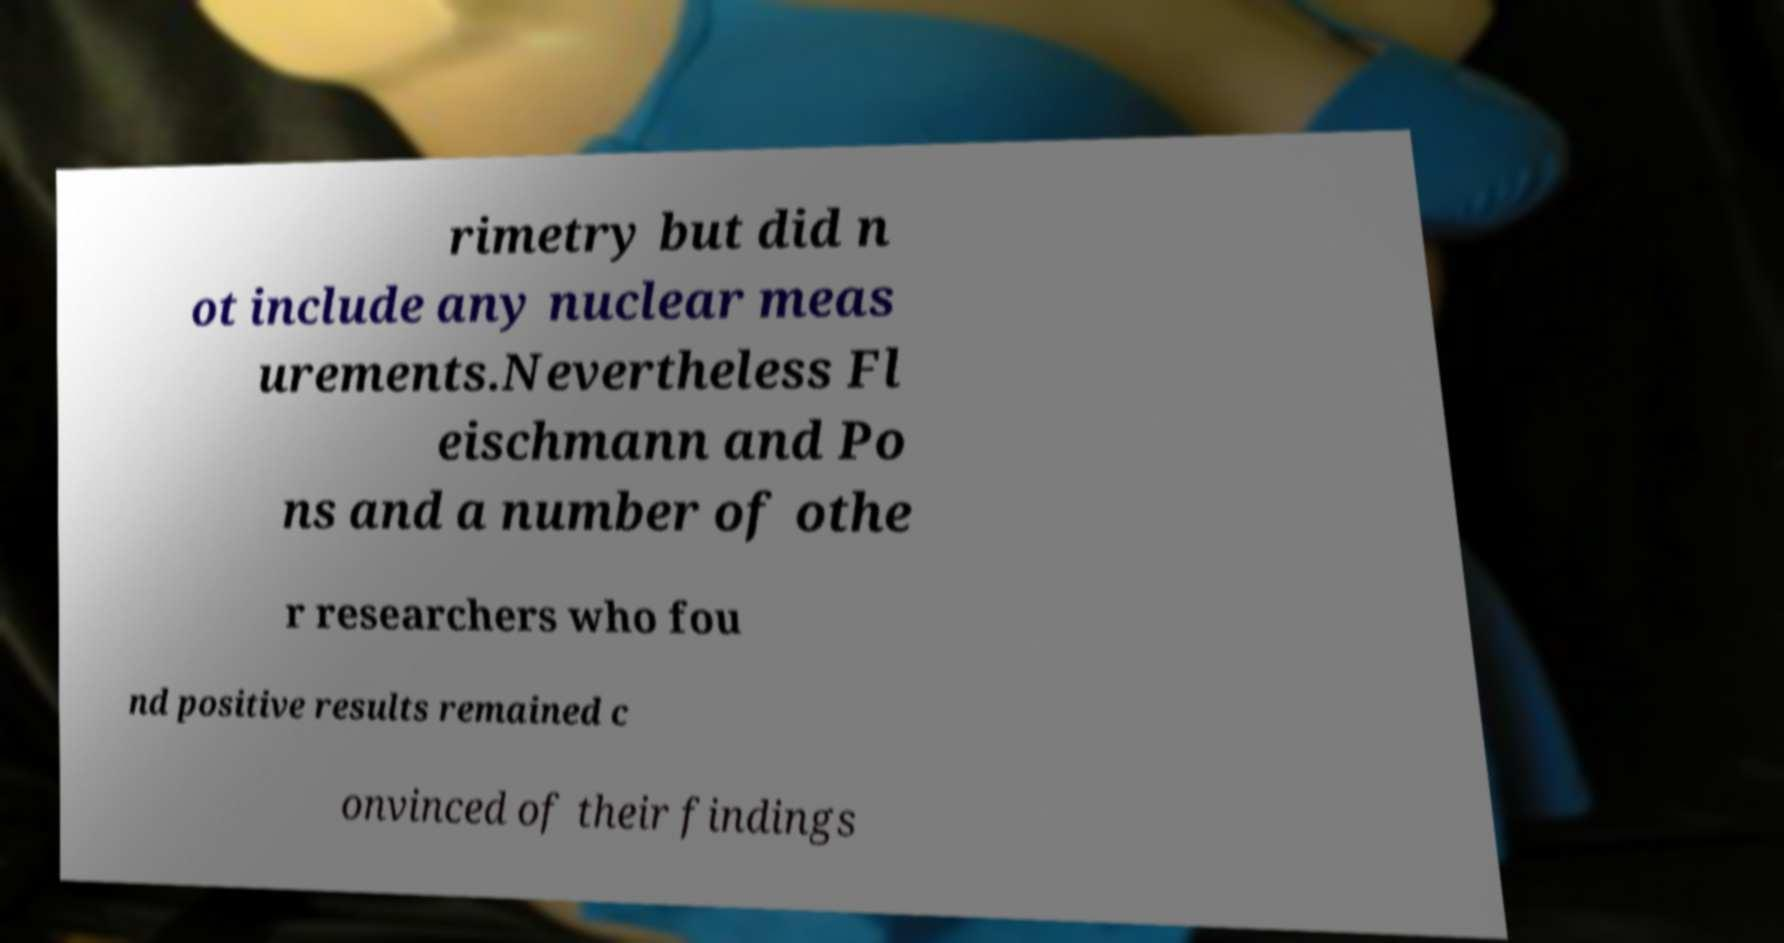Can you read and provide the text displayed in the image?This photo seems to have some interesting text. Can you extract and type it out for me? rimetry but did n ot include any nuclear meas urements.Nevertheless Fl eischmann and Po ns and a number of othe r researchers who fou nd positive results remained c onvinced of their findings 